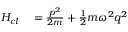Convert formula to latex. <formula><loc_0><loc_0><loc_500><loc_500>\begin{array} { r l } { H _ { c l } } & = { \frac { p ^ { 2 } } { 2 m } } + { \frac { 1 } { 2 } } m \omega ^ { 2 } { q } ^ { 2 } } \end{array}</formula> 